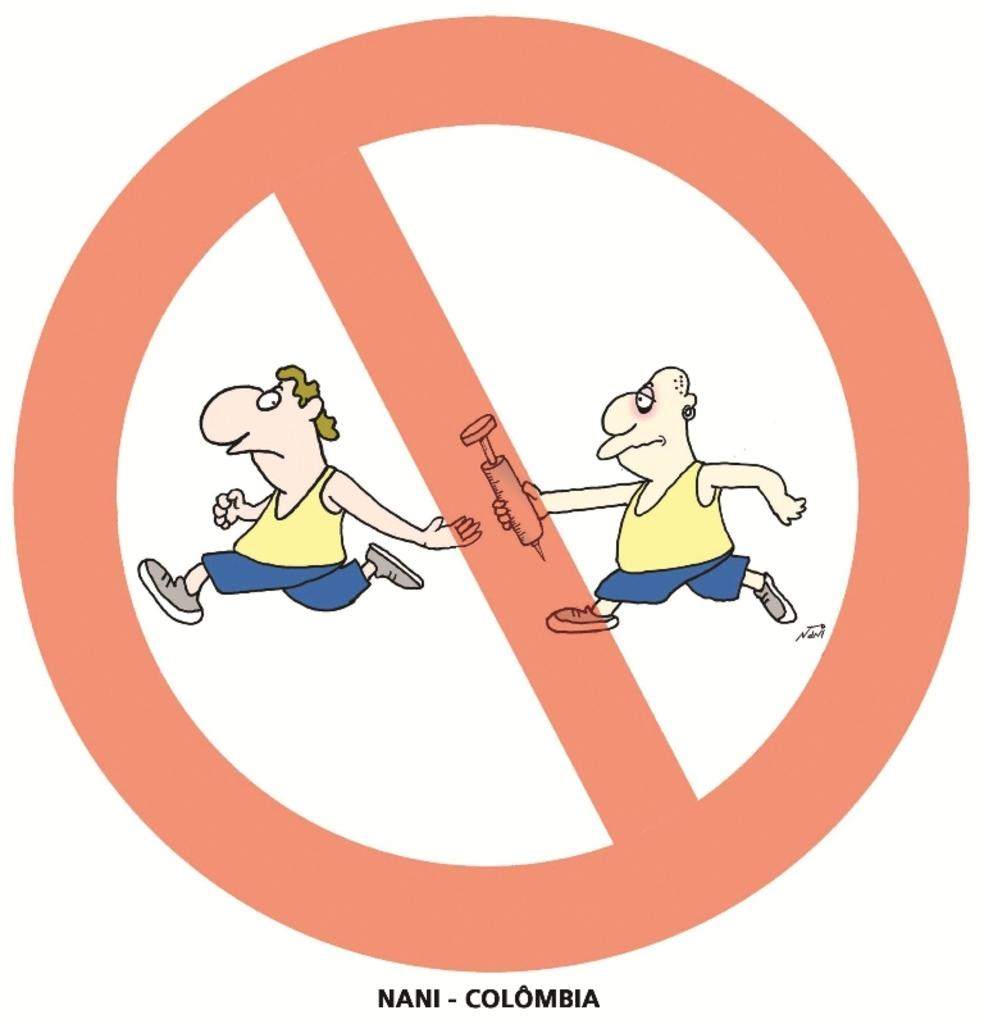What is present in the image? There is a poster in the image. What can be seen on the poster? The poster contains a person holding an object and another person running. What type of chin can be seen on the person running in the poster? There is no chin visible on the person running in the poster, as the image is a drawing or illustration and does not depict actual human features. 